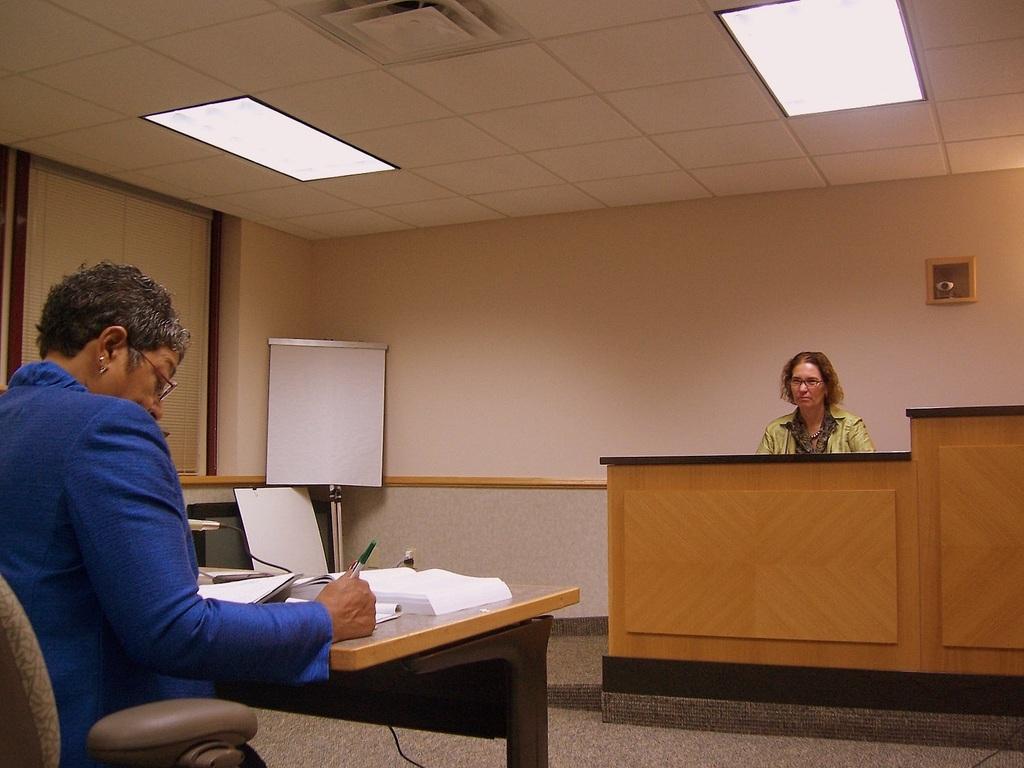In one or two sentences, can you explain what this image depicts? In this image i can see a person sitting and writing in a book on a table at the back ground i can see a woman sitting, a board, wall at the top there is a light. 